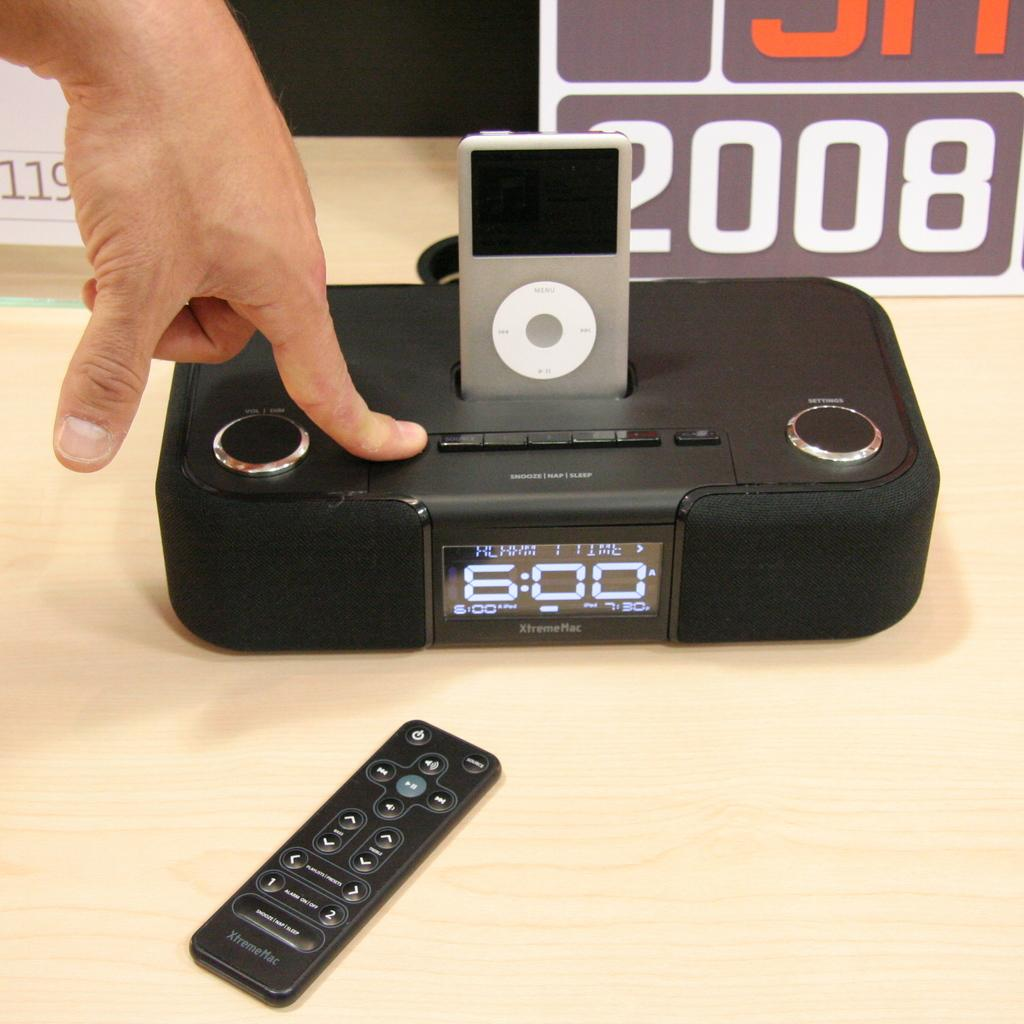Provide a one-sentence caption for the provided image. hand on an xtrememac clock radio with ipod holder. 